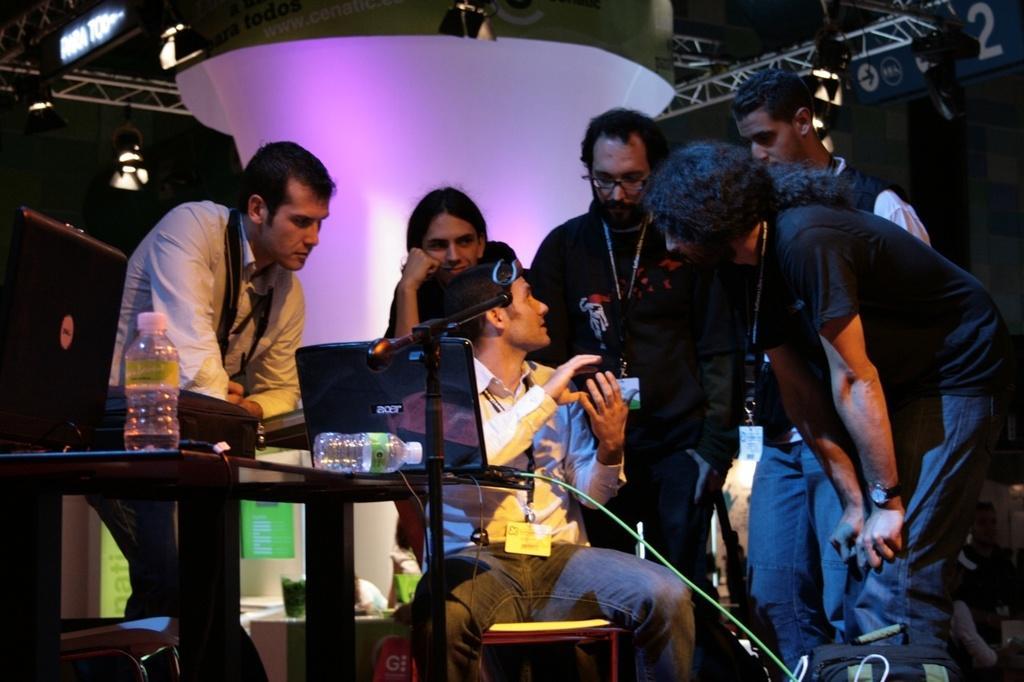In one or two sentences, can you explain what this image depicts? In this picture there is a person sitting and talking. At the back there are group of people standing. On the left side of the image there is a laptop, bag and there are bottles on the table and there is a chair. In the foreground there is a stand. At the top there are lights. In the top right there is a board. 